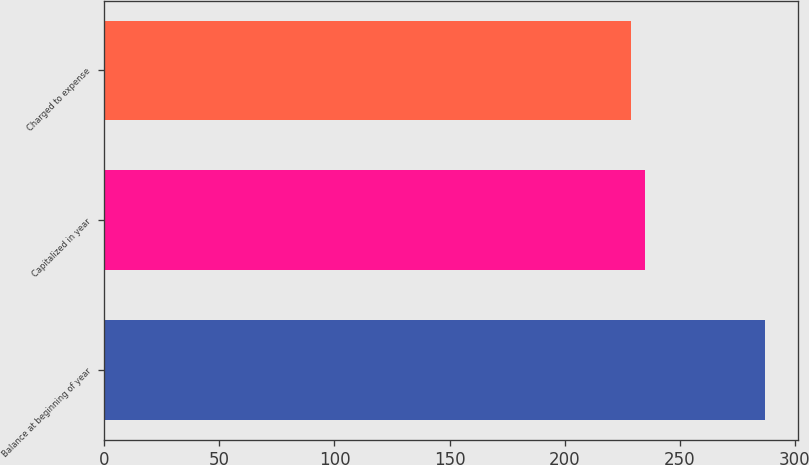Convert chart to OTSL. <chart><loc_0><loc_0><loc_500><loc_500><bar_chart><fcel>Balance at beginning of year<fcel>Capitalized in year<fcel>Charged to expense<nl><fcel>287<fcel>234.8<fcel>229<nl></chart> 